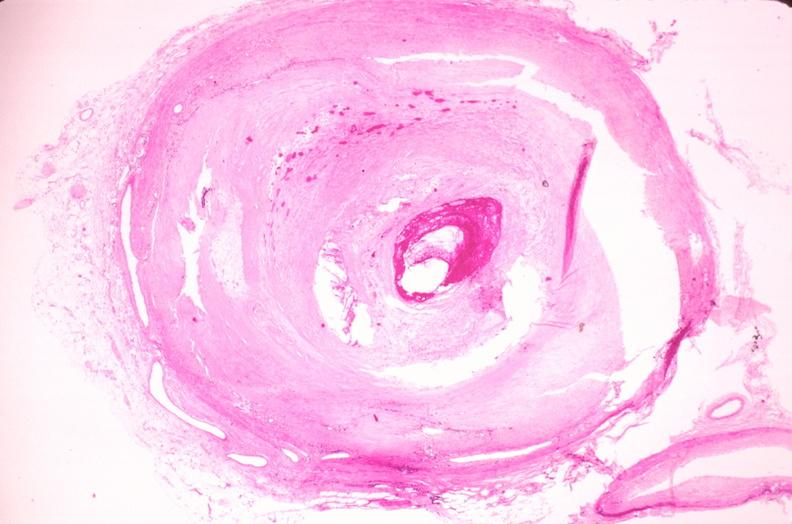s vasculature present?
Answer the question using a single word or phrase. Yes 